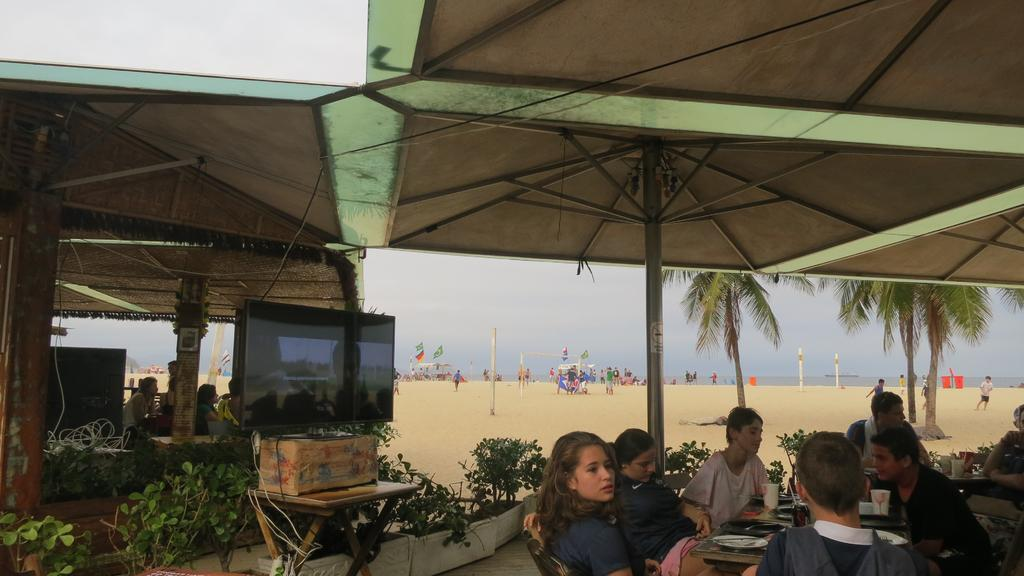Who or what can be seen in the image? There are people in the image. What are the people doing in the image? The people are sitting on chairs. What can be seen in the distance behind the people? There is a beach visible in the background of the image. How many geese are present on the beach in the image? There are no geese visible in the image; it only shows people sitting on chairs with a beach in the background. 